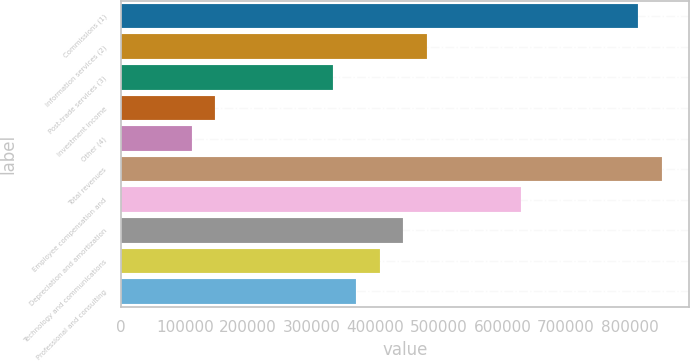Convert chart to OTSL. <chart><loc_0><loc_0><loc_500><loc_500><bar_chart><fcel>Commissions (1)<fcel>Information services (2)<fcel>Post-trade services (3)<fcel>Investment income<fcel>Other (4)<fcel>Total revenues<fcel>Employee compensation and<fcel>Depreciation and amortization<fcel>Technology and communications<fcel>Professional and consulting<nl><fcel>813821<fcel>480894<fcel>332927<fcel>147968<fcel>110976<fcel>850812<fcel>628862<fcel>443903<fcel>406911<fcel>369919<nl></chart> 